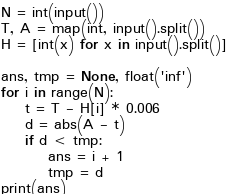<code> <loc_0><loc_0><loc_500><loc_500><_Python_>N = int(input())
T, A = map(int, input().split())
H = [int(x) for x in input().split()]

ans, tmp = None, float('inf')
for i in range(N):
    t = T - H[i] * 0.006
    d = abs(A - t)
    if d < tmp:
        ans = i + 1
        tmp = d
print(ans)
</code> 